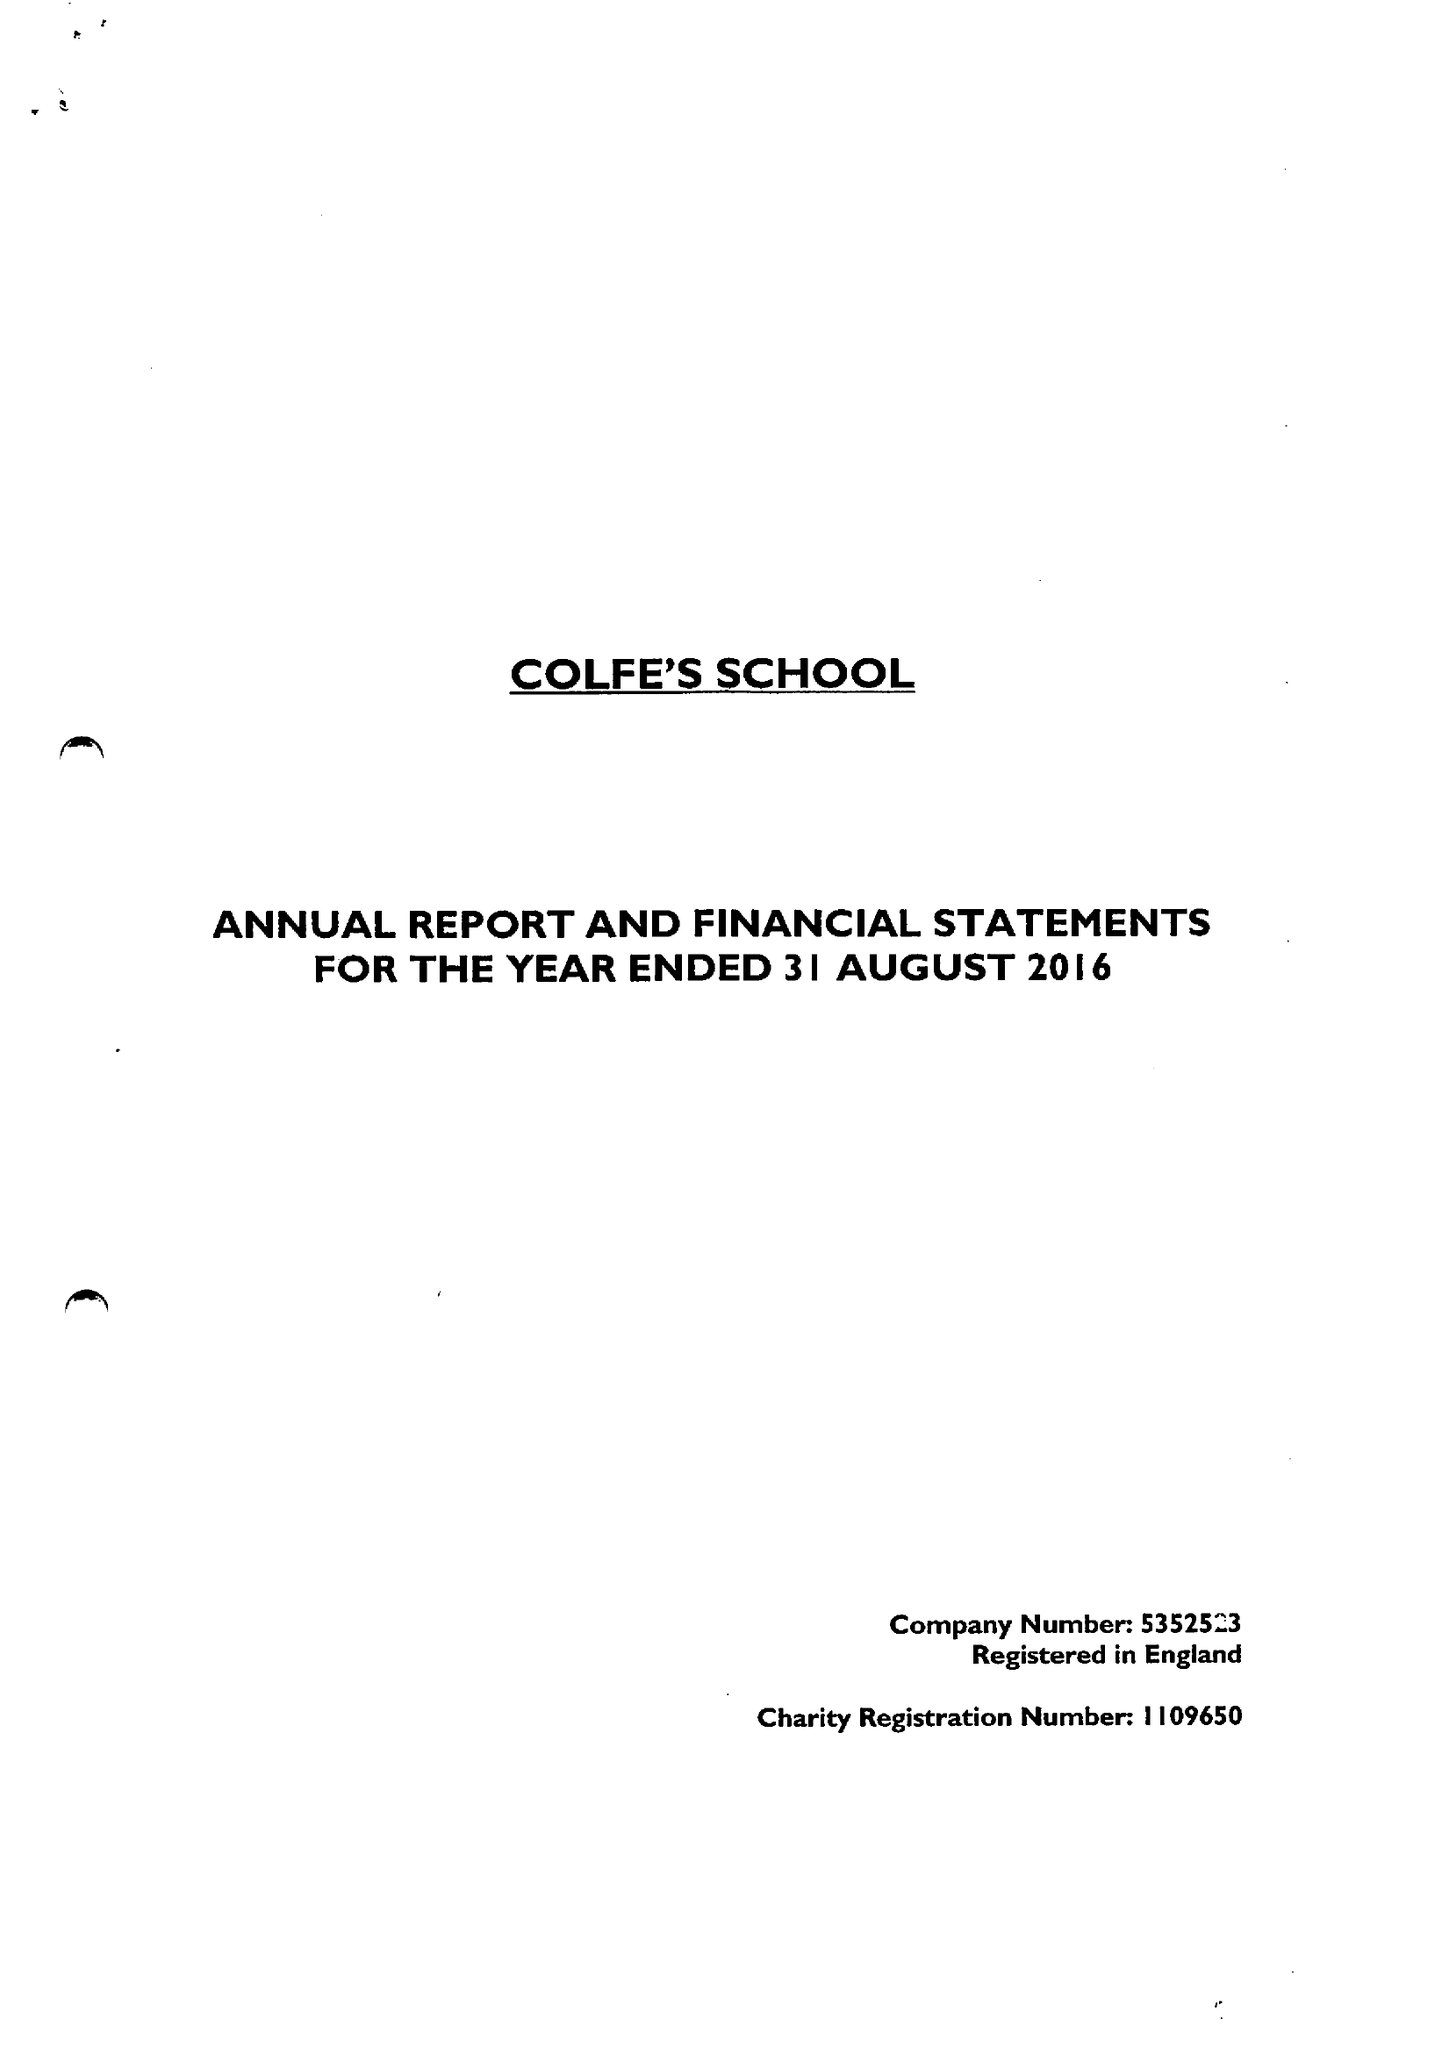What is the value for the address__postcode?
Answer the question using a single word or phrase. SE12 8AW 